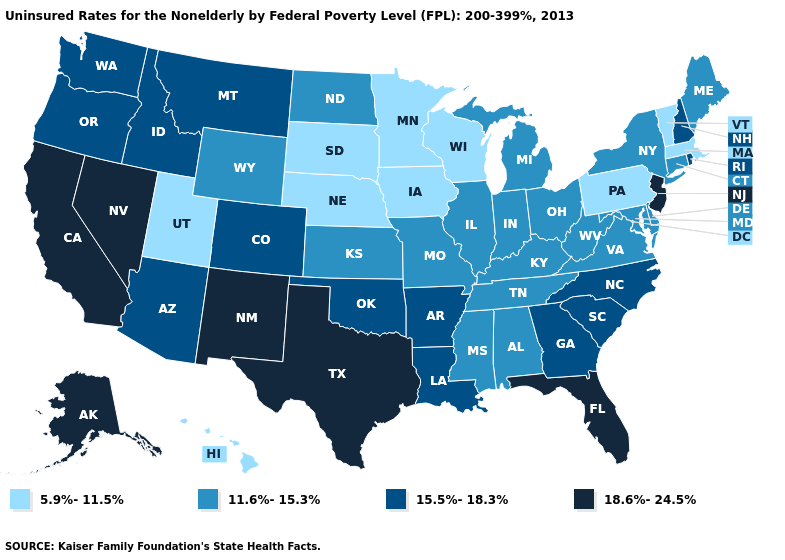What is the value of Alabama?
Short answer required. 11.6%-15.3%. Is the legend a continuous bar?
Write a very short answer. No. Does Colorado have the highest value in the USA?
Quick response, please. No. What is the lowest value in the Northeast?
Quick response, please. 5.9%-11.5%. What is the lowest value in the USA?
Write a very short answer. 5.9%-11.5%. Does New Jersey have the highest value in the USA?
Keep it brief. Yes. Which states have the lowest value in the USA?
Be succinct. Hawaii, Iowa, Massachusetts, Minnesota, Nebraska, Pennsylvania, South Dakota, Utah, Vermont, Wisconsin. What is the value of Arkansas?
Be succinct. 15.5%-18.3%. Does South Dakota have the highest value in the MidWest?
Keep it brief. No. Does Kentucky have a higher value than Wyoming?
Be succinct. No. Which states hav the highest value in the West?
Keep it brief. Alaska, California, Nevada, New Mexico. Among the states that border Iowa , which have the lowest value?
Be succinct. Minnesota, Nebraska, South Dakota, Wisconsin. Which states have the highest value in the USA?
Short answer required. Alaska, California, Florida, Nevada, New Jersey, New Mexico, Texas. What is the value of Minnesota?
Write a very short answer. 5.9%-11.5%. What is the lowest value in the USA?
Write a very short answer. 5.9%-11.5%. 